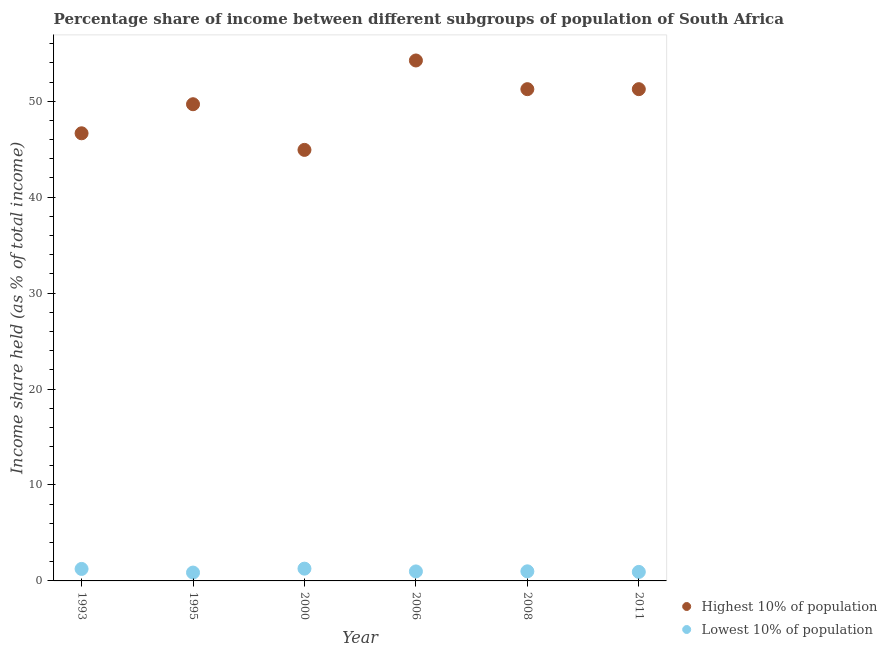Is the number of dotlines equal to the number of legend labels?
Give a very brief answer. Yes. What is the income share held by lowest 10% of the population in 2008?
Your response must be concise. 1. Across all years, what is the maximum income share held by highest 10% of the population?
Ensure brevity in your answer.  54.25. Across all years, what is the minimum income share held by highest 10% of the population?
Make the answer very short. 44.93. What is the total income share held by lowest 10% of the population in the graph?
Provide a short and direct response. 6.33. What is the difference between the income share held by highest 10% of the population in 1993 and the income share held by lowest 10% of the population in 2008?
Offer a terse response. 45.66. What is the average income share held by highest 10% of the population per year?
Make the answer very short. 49.68. In the year 2008, what is the difference between the income share held by highest 10% of the population and income share held by lowest 10% of the population?
Provide a succinct answer. 50.26. In how many years, is the income share held by lowest 10% of the population greater than 42 %?
Provide a succinct answer. 0. What is the ratio of the income share held by highest 10% of the population in 1993 to that in 2006?
Make the answer very short. 0.86. Is the income share held by lowest 10% of the population in 1993 less than that in 2008?
Give a very brief answer. No. Is the difference between the income share held by highest 10% of the population in 1993 and 2011 greater than the difference between the income share held by lowest 10% of the population in 1993 and 2011?
Provide a short and direct response. No. What is the difference between the highest and the second highest income share held by lowest 10% of the population?
Give a very brief answer. 0.03. What is the difference between the highest and the lowest income share held by highest 10% of the population?
Make the answer very short. 9.32. Does the income share held by highest 10% of the population monotonically increase over the years?
Your response must be concise. No. Is the income share held by lowest 10% of the population strictly less than the income share held by highest 10% of the population over the years?
Offer a very short reply. Yes. Are the values on the major ticks of Y-axis written in scientific E-notation?
Offer a terse response. No. Where does the legend appear in the graph?
Provide a succinct answer. Bottom right. How are the legend labels stacked?
Your answer should be compact. Vertical. What is the title of the graph?
Your answer should be compact. Percentage share of income between different subgroups of population of South Africa. Does "Diarrhea" appear as one of the legend labels in the graph?
Provide a succinct answer. No. What is the label or title of the X-axis?
Your answer should be very brief. Year. What is the label or title of the Y-axis?
Give a very brief answer. Income share held (as % of total income). What is the Income share held (as % of total income) of Highest 10% of population in 1993?
Make the answer very short. 46.66. What is the Income share held (as % of total income) of Highest 10% of population in 1995?
Ensure brevity in your answer.  49.69. What is the Income share held (as % of total income) in Lowest 10% of population in 1995?
Your answer should be compact. 0.87. What is the Income share held (as % of total income) of Highest 10% of population in 2000?
Make the answer very short. 44.93. What is the Income share held (as % of total income) of Lowest 10% of population in 2000?
Your response must be concise. 1.28. What is the Income share held (as % of total income) in Highest 10% of population in 2006?
Your answer should be very brief. 54.25. What is the Income share held (as % of total income) in Highest 10% of population in 2008?
Make the answer very short. 51.26. What is the Income share held (as % of total income) of Lowest 10% of population in 2008?
Offer a terse response. 1. What is the Income share held (as % of total income) of Highest 10% of population in 2011?
Your answer should be compact. 51.26. What is the Income share held (as % of total income) of Lowest 10% of population in 2011?
Keep it short and to the point. 0.94. Across all years, what is the maximum Income share held (as % of total income) in Highest 10% of population?
Give a very brief answer. 54.25. Across all years, what is the maximum Income share held (as % of total income) of Lowest 10% of population?
Your answer should be very brief. 1.28. Across all years, what is the minimum Income share held (as % of total income) of Highest 10% of population?
Offer a terse response. 44.93. Across all years, what is the minimum Income share held (as % of total income) in Lowest 10% of population?
Your response must be concise. 0.87. What is the total Income share held (as % of total income) of Highest 10% of population in the graph?
Keep it short and to the point. 298.05. What is the total Income share held (as % of total income) in Lowest 10% of population in the graph?
Ensure brevity in your answer.  6.33. What is the difference between the Income share held (as % of total income) in Highest 10% of population in 1993 and that in 1995?
Keep it short and to the point. -3.03. What is the difference between the Income share held (as % of total income) in Lowest 10% of population in 1993 and that in 1995?
Your response must be concise. 0.38. What is the difference between the Income share held (as % of total income) in Highest 10% of population in 1993 and that in 2000?
Your answer should be very brief. 1.73. What is the difference between the Income share held (as % of total income) in Lowest 10% of population in 1993 and that in 2000?
Give a very brief answer. -0.03. What is the difference between the Income share held (as % of total income) in Highest 10% of population in 1993 and that in 2006?
Keep it short and to the point. -7.59. What is the difference between the Income share held (as % of total income) of Lowest 10% of population in 1993 and that in 2006?
Provide a short and direct response. 0.26. What is the difference between the Income share held (as % of total income) in Lowest 10% of population in 1993 and that in 2008?
Provide a succinct answer. 0.25. What is the difference between the Income share held (as % of total income) in Highest 10% of population in 1993 and that in 2011?
Your answer should be very brief. -4.6. What is the difference between the Income share held (as % of total income) of Lowest 10% of population in 1993 and that in 2011?
Offer a terse response. 0.31. What is the difference between the Income share held (as % of total income) of Highest 10% of population in 1995 and that in 2000?
Offer a terse response. 4.76. What is the difference between the Income share held (as % of total income) in Lowest 10% of population in 1995 and that in 2000?
Offer a terse response. -0.41. What is the difference between the Income share held (as % of total income) of Highest 10% of population in 1995 and that in 2006?
Provide a succinct answer. -4.56. What is the difference between the Income share held (as % of total income) in Lowest 10% of population in 1995 and that in 2006?
Offer a terse response. -0.12. What is the difference between the Income share held (as % of total income) in Highest 10% of population in 1995 and that in 2008?
Give a very brief answer. -1.57. What is the difference between the Income share held (as % of total income) of Lowest 10% of population in 1995 and that in 2008?
Offer a very short reply. -0.13. What is the difference between the Income share held (as % of total income) in Highest 10% of population in 1995 and that in 2011?
Keep it short and to the point. -1.57. What is the difference between the Income share held (as % of total income) in Lowest 10% of population in 1995 and that in 2011?
Your answer should be compact. -0.07. What is the difference between the Income share held (as % of total income) of Highest 10% of population in 2000 and that in 2006?
Your answer should be very brief. -9.32. What is the difference between the Income share held (as % of total income) of Lowest 10% of population in 2000 and that in 2006?
Make the answer very short. 0.29. What is the difference between the Income share held (as % of total income) of Highest 10% of population in 2000 and that in 2008?
Offer a terse response. -6.33. What is the difference between the Income share held (as % of total income) of Lowest 10% of population in 2000 and that in 2008?
Give a very brief answer. 0.28. What is the difference between the Income share held (as % of total income) in Highest 10% of population in 2000 and that in 2011?
Give a very brief answer. -6.33. What is the difference between the Income share held (as % of total income) in Lowest 10% of population in 2000 and that in 2011?
Your answer should be compact. 0.34. What is the difference between the Income share held (as % of total income) of Highest 10% of population in 2006 and that in 2008?
Your response must be concise. 2.99. What is the difference between the Income share held (as % of total income) of Lowest 10% of population in 2006 and that in 2008?
Offer a terse response. -0.01. What is the difference between the Income share held (as % of total income) of Highest 10% of population in 2006 and that in 2011?
Your answer should be very brief. 2.99. What is the difference between the Income share held (as % of total income) of Highest 10% of population in 2008 and that in 2011?
Ensure brevity in your answer.  0. What is the difference between the Income share held (as % of total income) in Lowest 10% of population in 2008 and that in 2011?
Ensure brevity in your answer.  0.06. What is the difference between the Income share held (as % of total income) in Highest 10% of population in 1993 and the Income share held (as % of total income) in Lowest 10% of population in 1995?
Your response must be concise. 45.79. What is the difference between the Income share held (as % of total income) of Highest 10% of population in 1993 and the Income share held (as % of total income) of Lowest 10% of population in 2000?
Offer a very short reply. 45.38. What is the difference between the Income share held (as % of total income) in Highest 10% of population in 1993 and the Income share held (as % of total income) in Lowest 10% of population in 2006?
Your answer should be compact. 45.67. What is the difference between the Income share held (as % of total income) of Highest 10% of population in 1993 and the Income share held (as % of total income) of Lowest 10% of population in 2008?
Provide a short and direct response. 45.66. What is the difference between the Income share held (as % of total income) in Highest 10% of population in 1993 and the Income share held (as % of total income) in Lowest 10% of population in 2011?
Your answer should be very brief. 45.72. What is the difference between the Income share held (as % of total income) of Highest 10% of population in 1995 and the Income share held (as % of total income) of Lowest 10% of population in 2000?
Keep it short and to the point. 48.41. What is the difference between the Income share held (as % of total income) of Highest 10% of population in 1995 and the Income share held (as % of total income) of Lowest 10% of population in 2006?
Your answer should be very brief. 48.7. What is the difference between the Income share held (as % of total income) in Highest 10% of population in 1995 and the Income share held (as % of total income) in Lowest 10% of population in 2008?
Provide a succinct answer. 48.69. What is the difference between the Income share held (as % of total income) in Highest 10% of population in 1995 and the Income share held (as % of total income) in Lowest 10% of population in 2011?
Your response must be concise. 48.75. What is the difference between the Income share held (as % of total income) in Highest 10% of population in 2000 and the Income share held (as % of total income) in Lowest 10% of population in 2006?
Your response must be concise. 43.94. What is the difference between the Income share held (as % of total income) of Highest 10% of population in 2000 and the Income share held (as % of total income) of Lowest 10% of population in 2008?
Provide a succinct answer. 43.93. What is the difference between the Income share held (as % of total income) of Highest 10% of population in 2000 and the Income share held (as % of total income) of Lowest 10% of population in 2011?
Offer a terse response. 43.99. What is the difference between the Income share held (as % of total income) in Highest 10% of population in 2006 and the Income share held (as % of total income) in Lowest 10% of population in 2008?
Keep it short and to the point. 53.25. What is the difference between the Income share held (as % of total income) in Highest 10% of population in 2006 and the Income share held (as % of total income) in Lowest 10% of population in 2011?
Provide a succinct answer. 53.31. What is the difference between the Income share held (as % of total income) of Highest 10% of population in 2008 and the Income share held (as % of total income) of Lowest 10% of population in 2011?
Your response must be concise. 50.32. What is the average Income share held (as % of total income) of Highest 10% of population per year?
Your response must be concise. 49.67. What is the average Income share held (as % of total income) of Lowest 10% of population per year?
Keep it short and to the point. 1.05. In the year 1993, what is the difference between the Income share held (as % of total income) of Highest 10% of population and Income share held (as % of total income) of Lowest 10% of population?
Provide a succinct answer. 45.41. In the year 1995, what is the difference between the Income share held (as % of total income) of Highest 10% of population and Income share held (as % of total income) of Lowest 10% of population?
Keep it short and to the point. 48.82. In the year 2000, what is the difference between the Income share held (as % of total income) of Highest 10% of population and Income share held (as % of total income) of Lowest 10% of population?
Make the answer very short. 43.65. In the year 2006, what is the difference between the Income share held (as % of total income) in Highest 10% of population and Income share held (as % of total income) in Lowest 10% of population?
Keep it short and to the point. 53.26. In the year 2008, what is the difference between the Income share held (as % of total income) of Highest 10% of population and Income share held (as % of total income) of Lowest 10% of population?
Provide a short and direct response. 50.26. In the year 2011, what is the difference between the Income share held (as % of total income) of Highest 10% of population and Income share held (as % of total income) of Lowest 10% of population?
Provide a succinct answer. 50.32. What is the ratio of the Income share held (as % of total income) in Highest 10% of population in 1993 to that in 1995?
Offer a terse response. 0.94. What is the ratio of the Income share held (as % of total income) of Lowest 10% of population in 1993 to that in 1995?
Keep it short and to the point. 1.44. What is the ratio of the Income share held (as % of total income) of Lowest 10% of population in 1993 to that in 2000?
Offer a very short reply. 0.98. What is the ratio of the Income share held (as % of total income) in Highest 10% of population in 1993 to that in 2006?
Give a very brief answer. 0.86. What is the ratio of the Income share held (as % of total income) of Lowest 10% of population in 1993 to that in 2006?
Your answer should be very brief. 1.26. What is the ratio of the Income share held (as % of total income) in Highest 10% of population in 1993 to that in 2008?
Give a very brief answer. 0.91. What is the ratio of the Income share held (as % of total income) in Lowest 10% of population in 1993 to that in 2008?
Your answer should be very brief. 1.25. What is the ratio of the Income share held (as % of total income) of Highest 10% of population in 1993 to that in 2011?
Make the answer very short. 0.91. What is the ratio of the Income share held (as % of total income) in Lowest 10% of population in 1993 to that in 2011?
Ensure brevity in your answer.  1.33. What is the ratio of the Income share held (as % of total income) of Highest 10% of population in 1995 to that in 2000?
Make the answer very short. 1.11. What is the ratio of the Income share held (as % of total income) in Lowest 10% of population in 1995 to that in 2000?
Give a very brief answer. 0.68. What is the ratio of the Income share held (as % of total income) of Highest 10% of population in 1995 to that in 2006?
Keep it short and to the point. 0.92. What is the ratio of the Income share held (as % of total income) of Lowest 10% of population in 1995 to that in 2006?
Offer a terse response. 0.88. What is the ratio of the Income share held (as % of total income) in Highest 10% of population in 1995 to that in 2008?
Ensure brevity in your answer.  0.97. What is the ratio of the Income share held (as % of total income) in Lowest 10% of population in 1995 to that in 2008?
Give a very brief answer. 0.87. What is the ratio of the Income share held (as % of total income) in Highest 10% of population in 1995 to that in 2011?
Ensure brevity in your answer.  0.97. What is the ratio of the Income share held (as % of total income) in Lowest 10% of population in 1995 to that in 2011?
Offer a terse response. 0.93. What is the ratio of the Income share held (as % of total income) in Highest 10% of population in 2000 to that in 2006?
Keep it short and to the point. 0.83. What is the ratio of the Income share held (as % of total income) of Lowest 10% of population in 2000 to that in 2006?
Offer a very short reply. 1.29. What is the ratio of the Income share held (as % of total income) in Highest 10% of population in 2000 to that in 2008?
Your answer should be very brief. 0.88. What is the ratio of the Income share held (as % of total income) of Lowest 10% of population in 2000 to that in 2008?
Your answer should be very brief. 1.28. What is the ratio of the Income share held (as % of total income) in Highest 10% of population in 2000 to that in 2011?
Your answer should be compact. 0.88. What is the ratio of the Income share held (as % of total income) in Lowest 10% of population in 2000 to that in 2011?
Your response must be concise. 1.36. What is the ratio of the Income share held (as % of total income) of Highest 10% of population in 2006 to that in 2008?
Offer a terse response. 1.06. What is the ratio of the Income share held (as % of total income) in Lowest 10% of population in 2006 to that in 2008?
Provide a succinct answer. 0.99. What is the ratio of the Income share held (as % of total income) in Highest 10% of population in 2006 to that in 2011?
Ensure brevity in your answer.  1.06. What is the ratio of the Income share held (as % of total income) in Lowest 10% of population in 2006 to that in 2011?
Offer a terse response. 1.05. What is the ratio of the Income share held (as % of total income) in Highest 10% of population in 2008 to that in 2011?
Give a very brief answer. 1. What is the ratio of the Income share held (as % of total income) of Lowest 10% of population in 2008 to that in 2011?
Keep it short and to the point. 1.06. What is the difference between the highest and the second highest Income share held (as % of total income) in Highest 10% of population?
Make the answer very short. 2.99. What is the difference between the highest and the lowest Income share held (as % of total income) in Highest 10% of population?
Ensure brevity in your answer.  9.32. What is the difference between the highest and the lowest Income share held (as % of total income) in Lowest 10% of population?
Your answer should be compact. 0.41. 